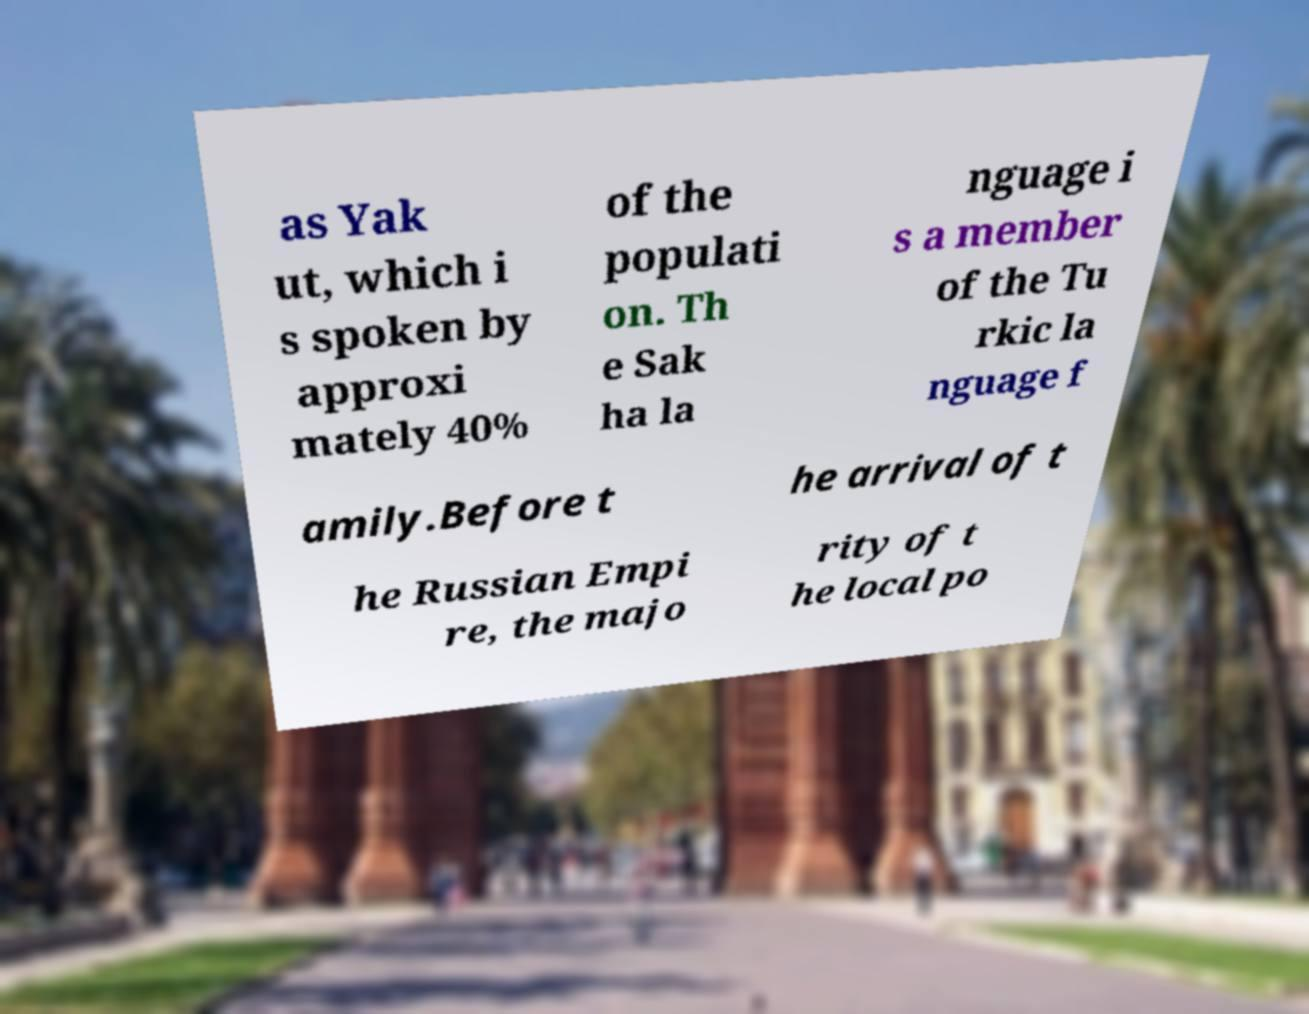There's text embedded in this image that I need extracted. Can you transcribe it verbatim? as Yak ut, which i s spoken by approxi mately 40% of the populati on. Th e Sak ha la nguage i s a member of the Tu rkic la nguage f amily.Before t he arrival of t he Russian Empi re, the majo rity of t he local po 